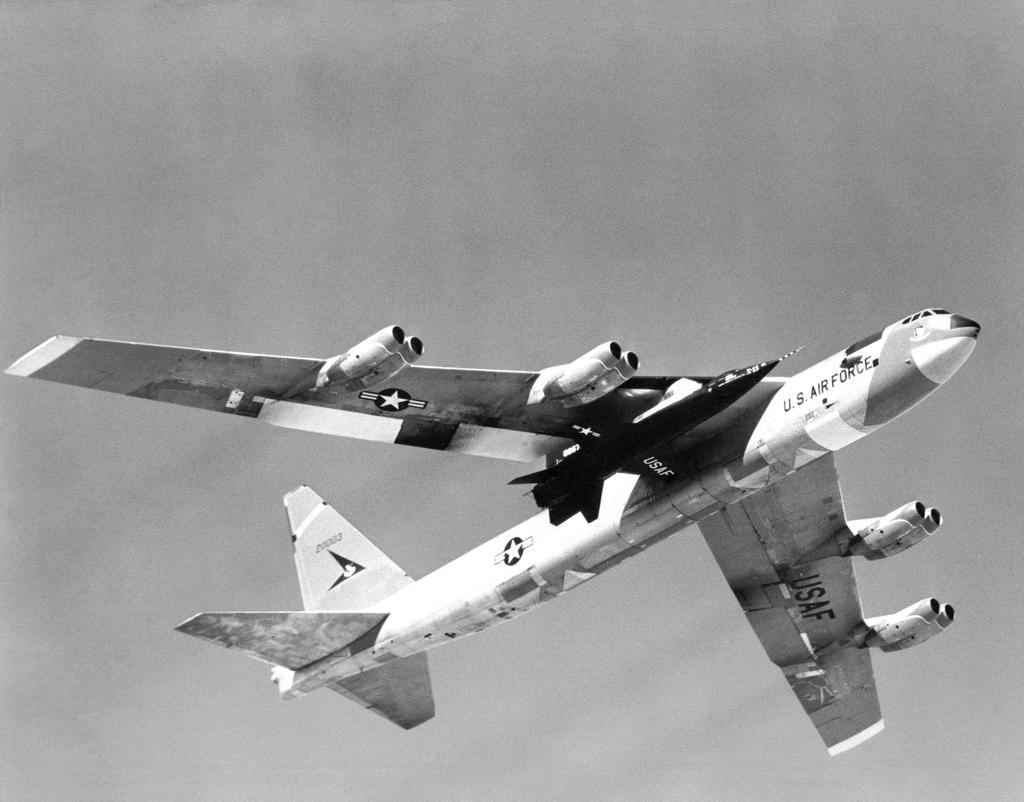What is the main subject of the image? The main subject of the image is a white color plane. What can be seen in the background of the image? The sky is visible in the image. What type of downtown area can be seen in the image? There is no downtown area present in the image; it features a white color plane and the sky. How many balloons are attached to the base of the plane in the image? There are no balloons or base present in the image; it only shows a white color plane and the sky. 